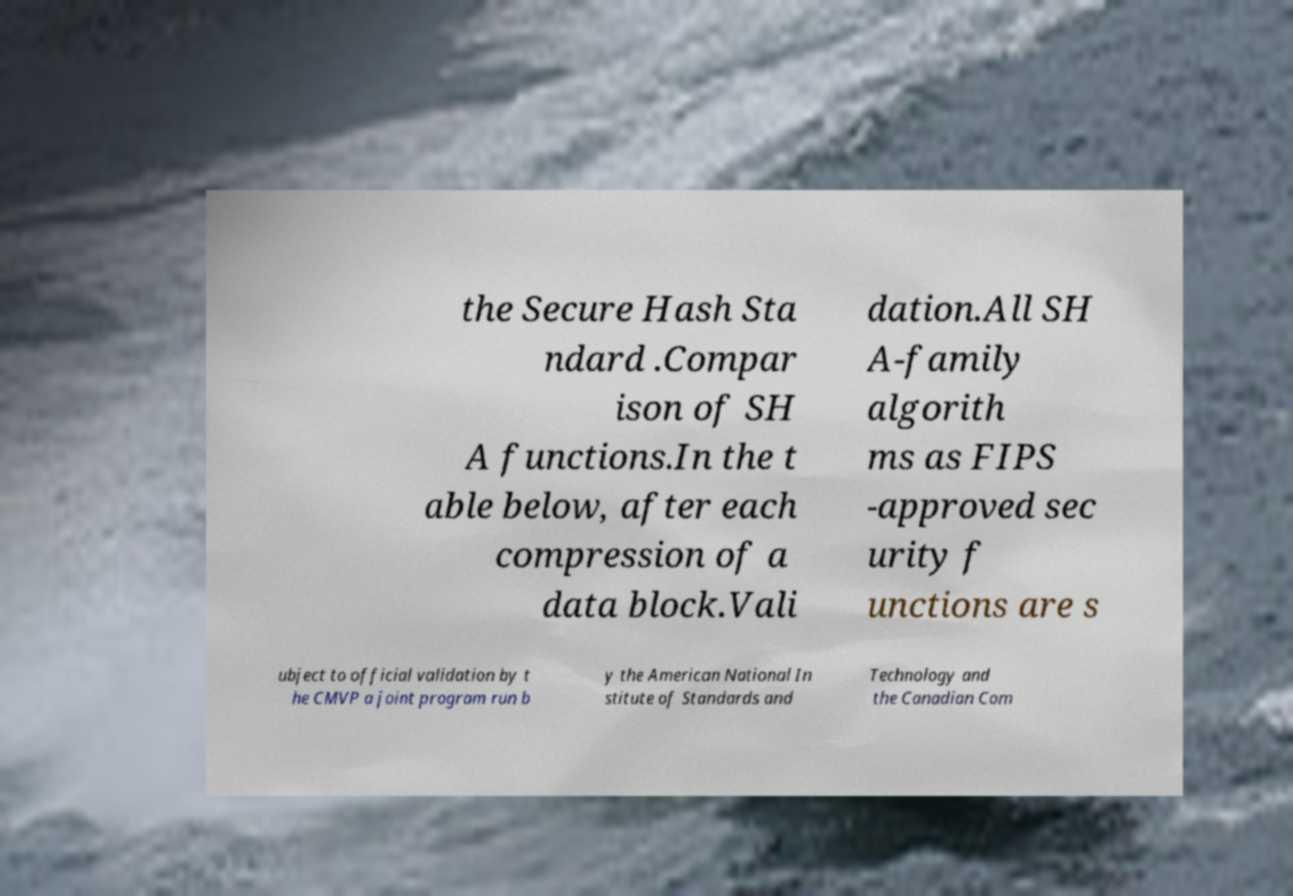I need the written content from this picture converted into text. Can you do that? the Secure Hash Sta ndard .Compar ison of SH A functions.In the t able below, after each compression of a data block.Vali dation.All SH A-family algorith ms as FIPS -approved sec urity f unctions are s ubject to official validation by t he CMVP a joint program run b y the American National In stitute of Standards and Technology and the Canadian Com 